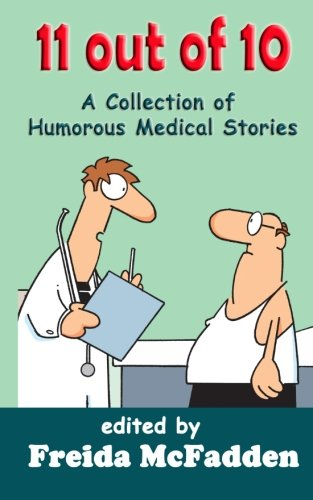What is the title of this book? The title of the book displayed is '11 out of 10: A Collection of Humorous Medical Short Stories,' which promises an entertaining read focusing on medical settings. 